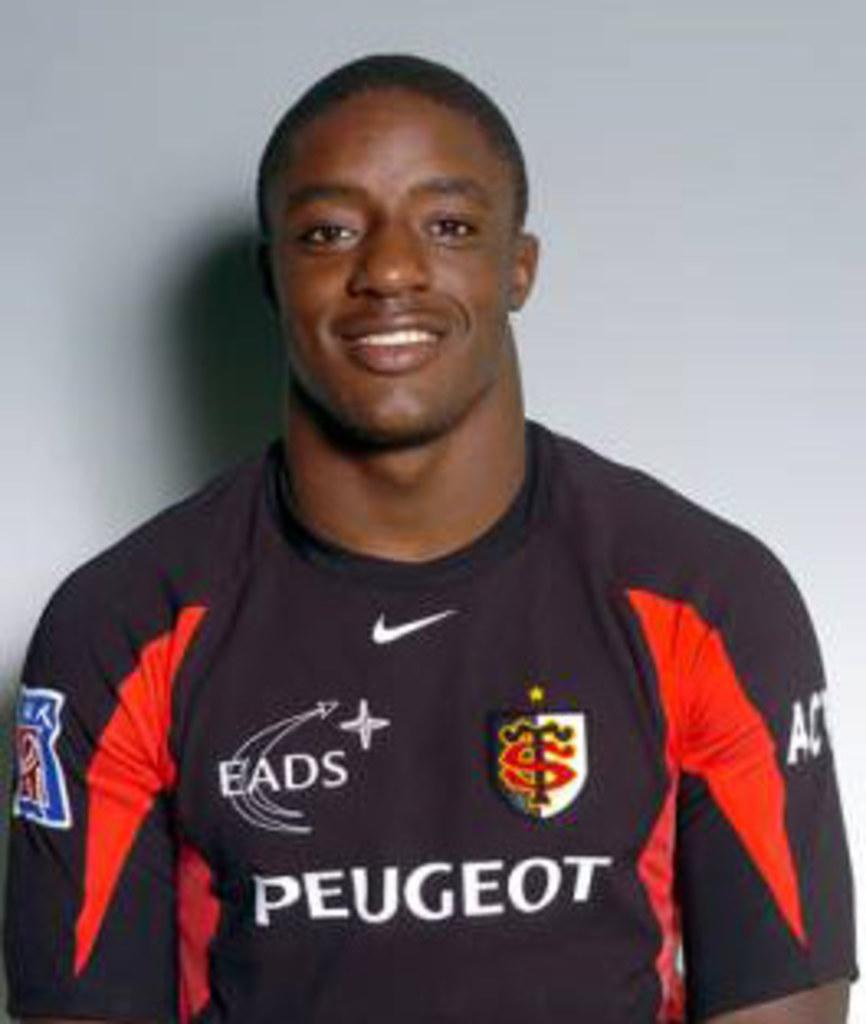<image>
Provide a brief description of the given image. A young African American man is standing against a white background wearing a team jersey that says Peugeot made by Nike. 